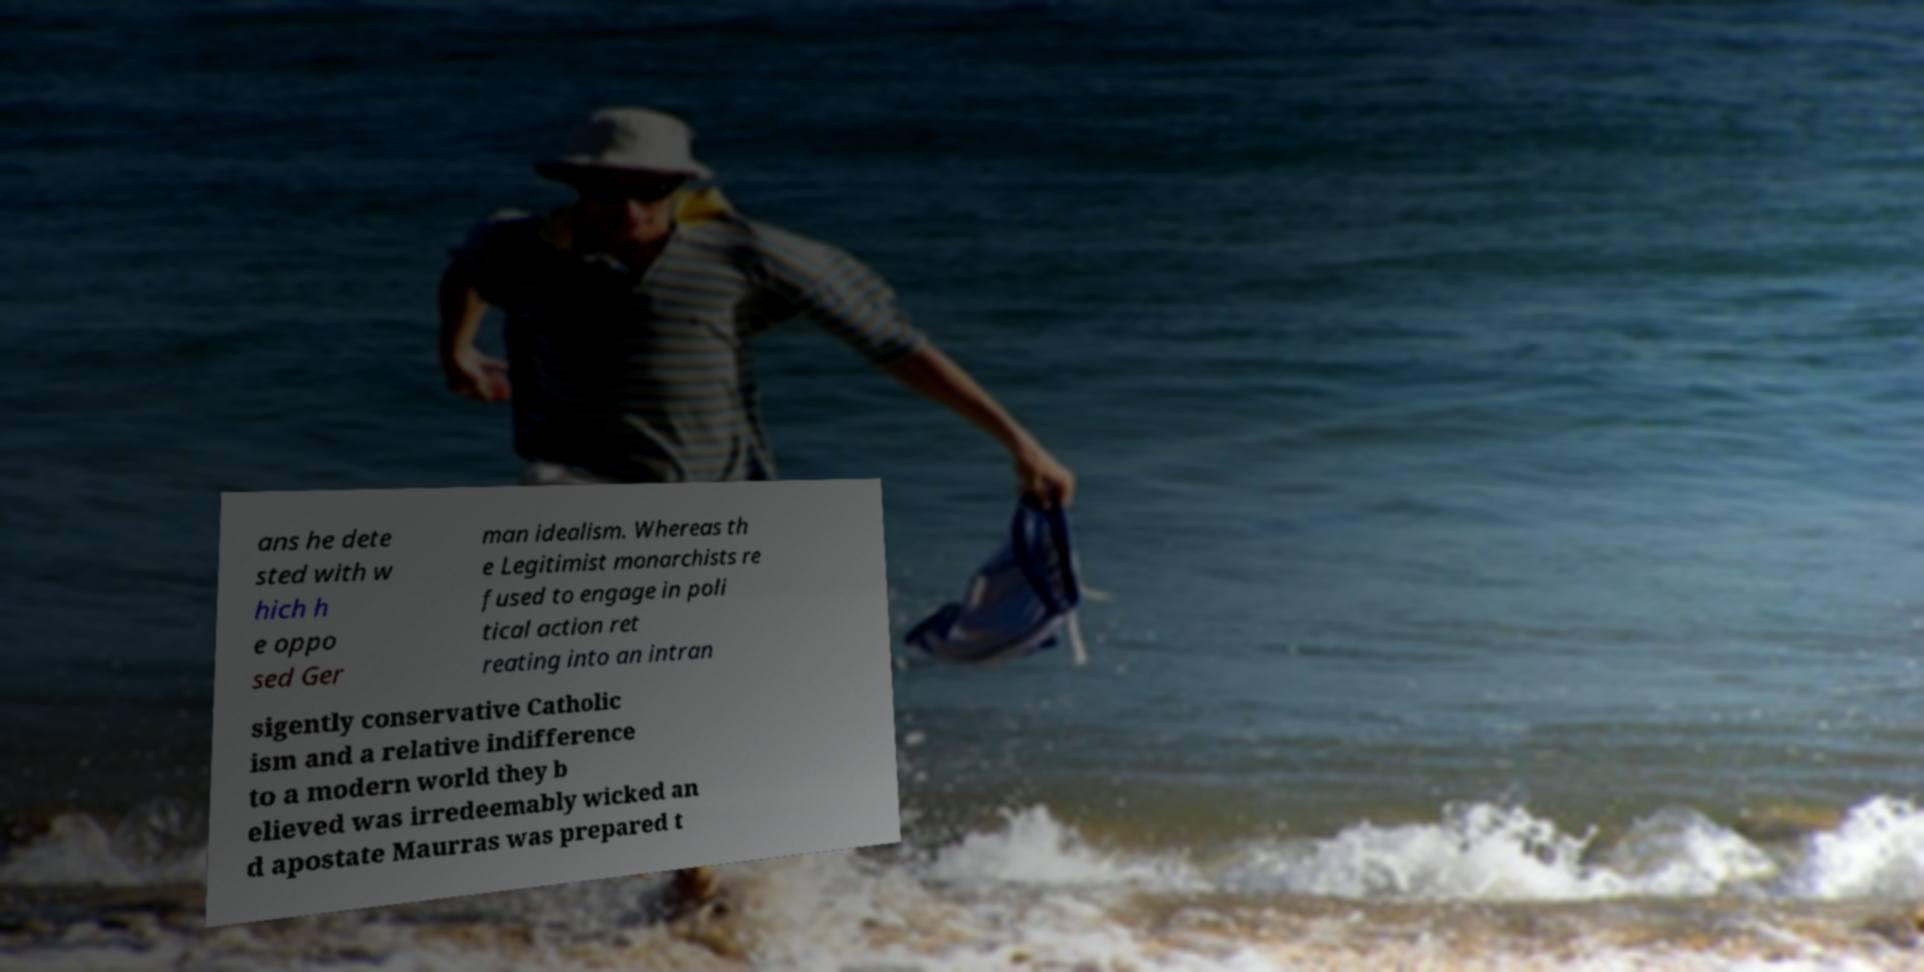Can you read and provide the text displayed in the image?This photo seems to have some interesting text. Can you extract and type it out for me? ans he dete sted with w hich h e oppo sed Ger man idealism. Whereas th e Legitimist monarchists re fused to engage in poli tical action ret reating into an intran sigently conservative Catholic ism and a relative indifference to a modern world they b elieved was irredeemably wicked an d apostate Maurras was prepared t 